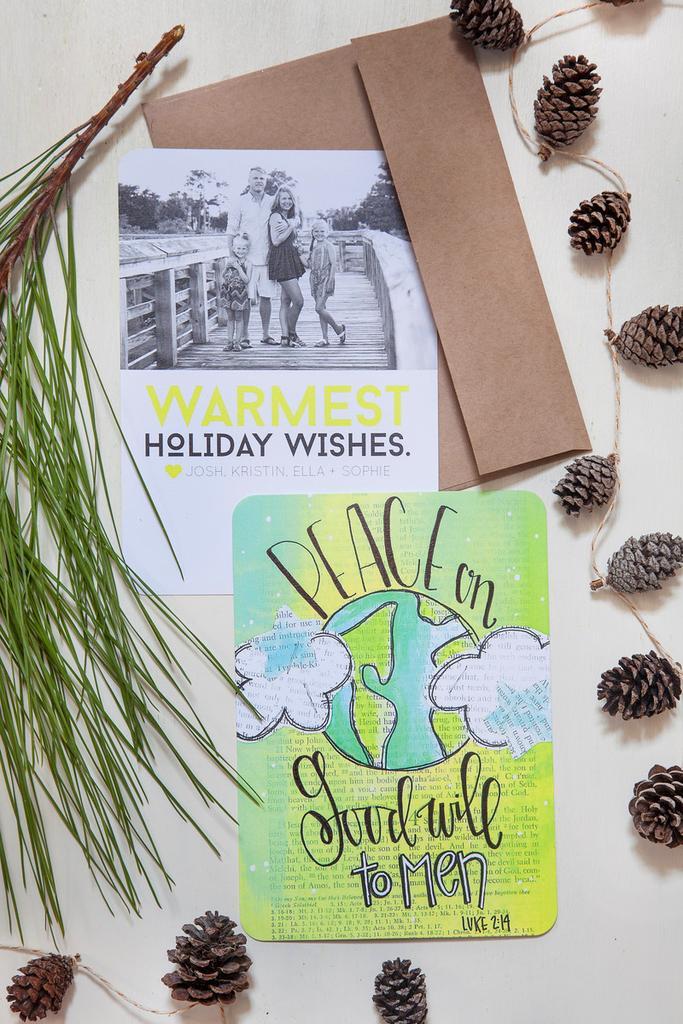Please provide a concise description of this image. In this image, we can see a wall, on the wall, we can see some posts are attached to it, on that posters, we can see some pictures and text written on it. On the right side, we can also see some flowers are attached. On the left side, we can see some leaves. 